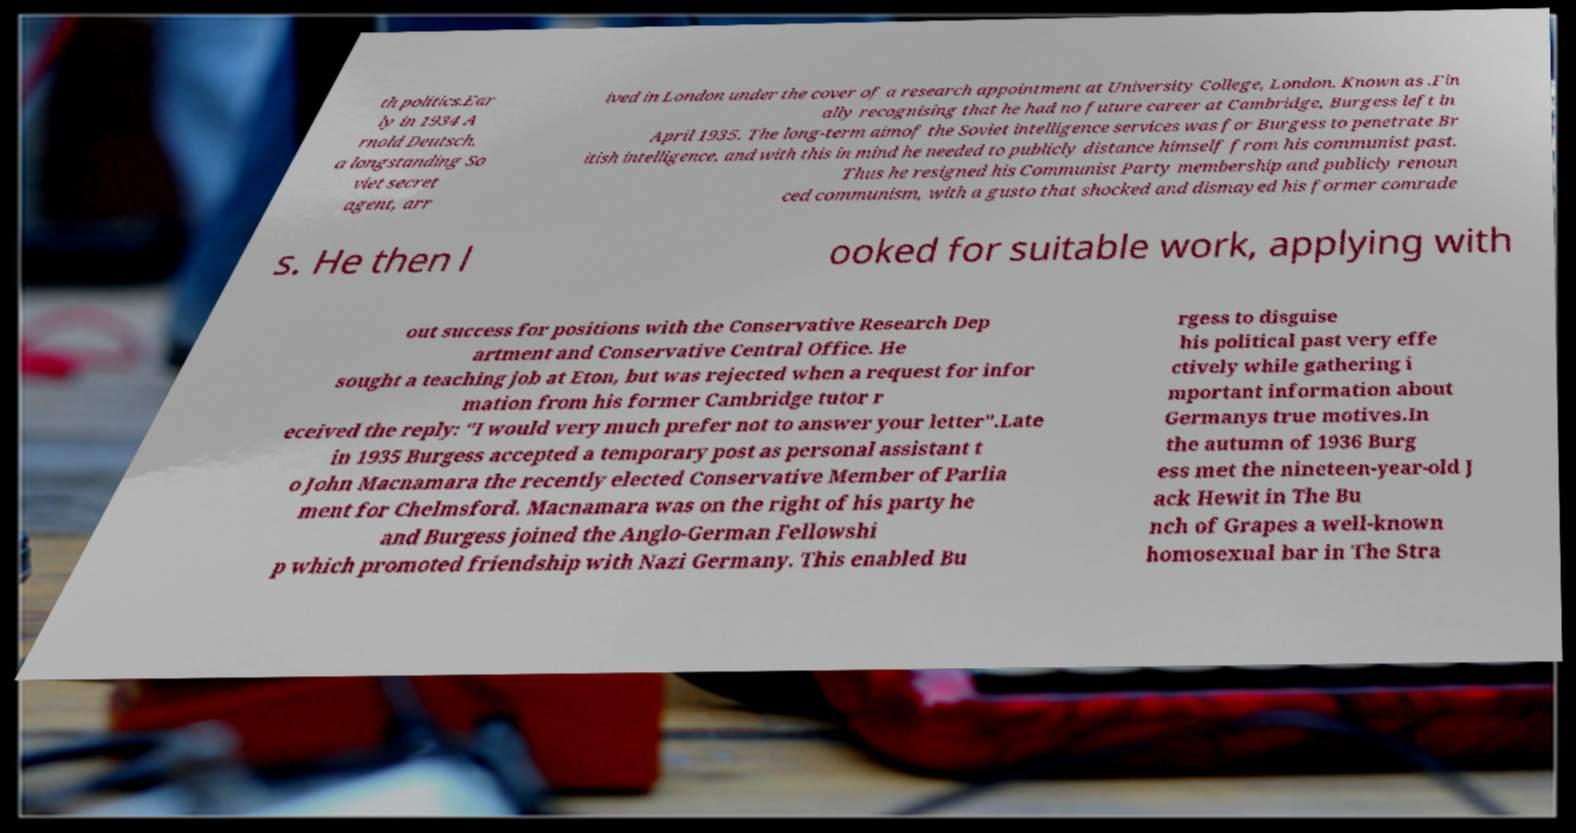Could you assist in decoding the text presented in this image and type it out clearly? th politics.Ear ly in 1934 A rnold Deutsch, a longstanding So viet secret agent, arr ived in London under the cover of a research appointment at University College, London. Known as .Fin ally recognising that he had no future career at Cambridge, Burgess left in April 1935. The long-term aimof the Soviet intelligence services was for Burgess to penetrate Br itish intelligence, and with this in mind he needed to publicly distance himself from his communist past. Thus he resigned his Communist Party membership and publicly renoun ced communism, with a gusto that shocked and dismayed his former comrade s. He then l ooked for suitable work, applying with out success for positions with the Conservative Research Dep artment and Conservative Central Office. He sought a teaching job at Eton, but was rejected when a request for infor mation from his former Cambridge tutor r eceived the reply: "I would very much prefer not to answer your letter".Late in 1935 Burgess accepted a temporary post as personal assistant t o John Macnamara the recently elected Conservative Member of Parlia ment for Chelmsford. Macnamara was on the right of his party he and Burgess joined the Anglo-German Fellowshi p which promoted friendship with Nazi Germany. This enabled Bu rgess to disguise his political past very effe ctively while gathering i mportant information about Germanys true motives.In the autumn of 1936 Burg ess met the nineteen-year-old J ack Hewit in The Bu nch of Grapes a well-known homosexual bar in The Stra 